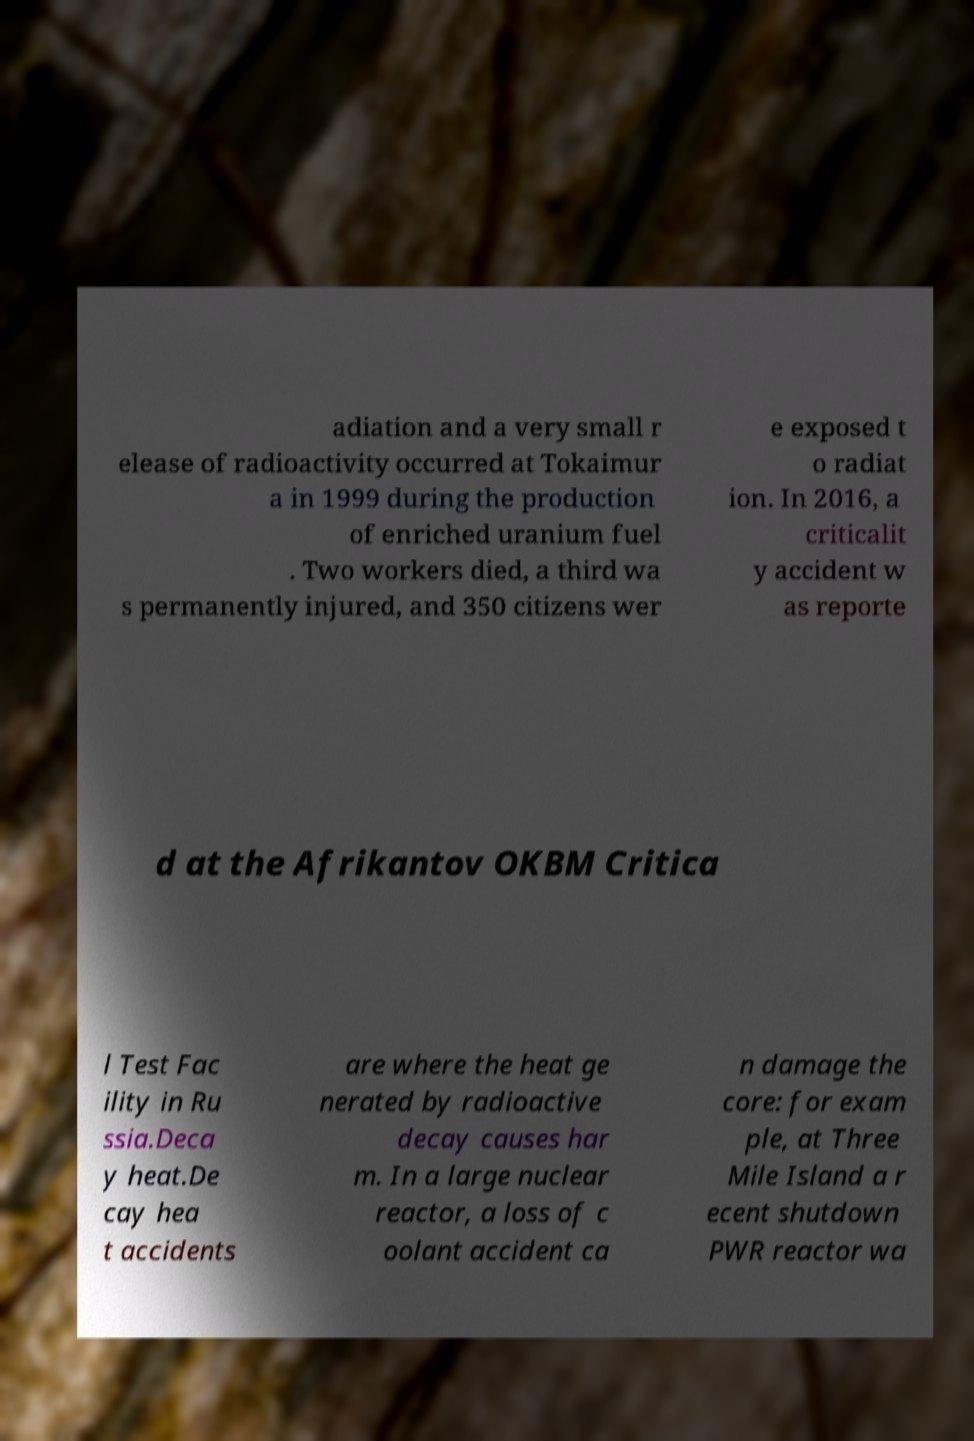For documentation purposes, I need the text within this image transcribed. Could you provide that? adiation and a very small r elease of radioactivity occurred at Tokaimur a in 1999 during the production of enriched uranium fuel . Two workers died, a third wa s permanently injured, and 350 citizens wer e exposed t o radiat ion. In 2016, a criticalit y accident w as reporte d at the Afrikantov OKBM Critica l Test Fac ility in Ru ssia.Deca y heat.De cay hea t accidents are where the heat ge nerated by radioactive decay causes har m. In a large nuclear reactor, a loss of c oolant accident ca n damage the core: for exam ple, at Three Mile Island a r ecent shutdown PWR reactor wa 